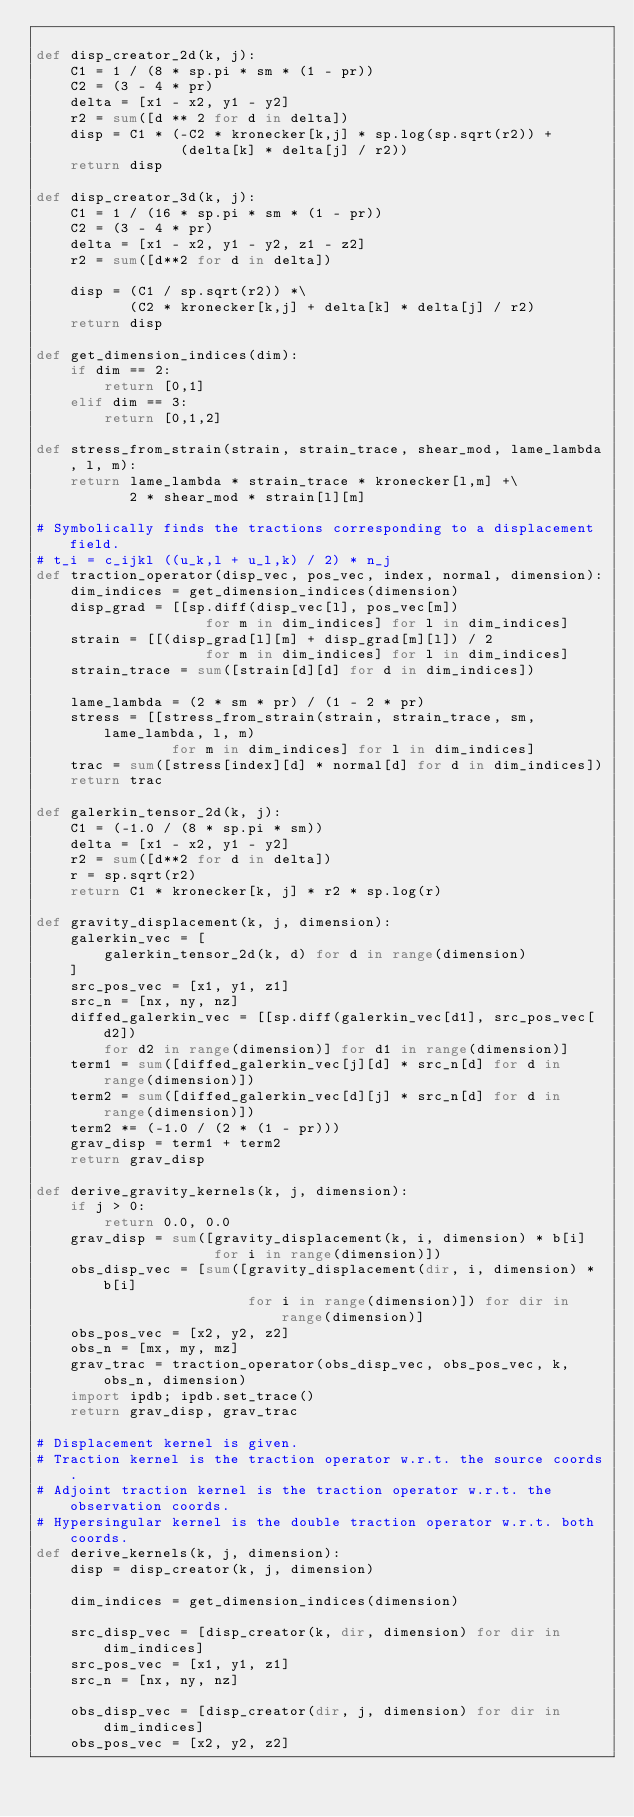Convert code to text. <code><loc_0><loc_0><loc_500><loc_500><_Python_>
def disp_creator_2d(k, j):
    C1 = 1 / (8 * sp.pi * sm * (1 - pr))
    C2 = (3 - 4 * pr)
    delta = [x1 - x2, y1 - y2]
    r2 = sum([d ** 2 for d in delta])
    disp = C1 * (-C2 * kronecker[k,j] * sp.log(sp.sqrt(r2)) +
                 (delta[k] * delta[j] / r2))
    return disp

def disp_creator_3d(k, j):
    C1 = 1 / (16 * sp.pi * sm * (1 - pr))
    C2 = (3 - 4 * pr)
    delta = [x1 - x2, y1 - y2, z1 - z2]
    r2 = sum([d**2 for d in delta])

    disp = (C1 / sp.sqrt(r2)) *\
           (C2 * kronecker[k,j] + delta[k] * delta[j] / r2)
    return disp

def get_dimension_indices(dim):
    if dim == 2:
        return [0,1]
    elif dim == 3:
        return [0,1,2]

def stress_from_strain(strain, strain_trace, shear_mod, lame_lambda, l, m):
    return lame_lambda * strain_trace * kronecker[l,m] +\
           2 * shear_mod * strain[l][m]

# Symbolically finds the tractions corresponding to a displacement field.
# t_i = c_ijkl ((u_k,l + u_l,k) / 2) * n_j
def traction_operator(disp_vec, pos_vec, index, normal, dimension):
    dim_indices = get_dimension_indices(dimension)
    disp_grad = [[sp.diff(disp_vec[l], pos_vec[m])
                    for m in dim_indices] for l in dim_indices]
    strain = [[(disp_grad[l][m] + disp_grad[m][l]) / 2
                    for m in dim_indices] for l in dim_indices]
    strain_trace = sum([strain[d][d] for d in dim_indices])

    lame_lambda = (2 * sm * pr) / (1 - 2 * pr)
    stress = [[stress_from_strain(strain, strain_trace, sm, lame_lambda, l, m)
                for m in dim_indices] for l in dim_indices]
    trac = sum([stress[index][d] * normal[d] for d in dim_indices])
    return trac

def galerkin_tensor_2d(k, j):
    C1 = (-1.0 / (8 * sp.pi * sm))
    delta = [x1 - x2, y1 - y2]
    r2 = sum([d**2 for d in delta])
    r = sp.sqrt(r2)
    return C1 * kronecker[k, j] * r2 * sp.log(r)

def gravity_displacement(k, j, dimension):
    galerkin_vec = [
        galerkin_tensor_2d(k, d) for d in range(dimension)
    ]
    src_pos_vec = [x1, y1, z1]
    src_n = [nx, ny, nz]
    diffed_galerkin_vec = [[sp.diff(galerkin_vec[d1], src_pos_vec[d2])
        for d2 in range(dimension)] for d1 in range(dimension)]
    term1 = sum([diffed_galerkin_vec[j][d] * src_n[d] for d in range(dimension)])
    term2 = sum([diffed_galerkin_vec[d][j] * src_n[d] for d in range(dimension)])
    term2 *= (-1.0 / (2 * (1 - pr)))
    grav_disp = term1 + term2
    return grav_disp

def derive_gravity_kernels(k, j, dimension):
    if j > 0:
        return 0.0, 0.0
    grav_disp = sum([gravity_displacement(k, i, dimension) * b[i]
                     for i in range(dimension)])
    obs_disp_vec = [sum([gravity_displacement(dir, i, dimension) * b[i]
                         for i in range(dimension)]) for dir in range(dimension)]
    obs_pos_vec = [x2, y2, z2]
    obs_n = [mx, my, mz]
    grav_trac = traction_operator(obs_disp_vec, obs_pos_vec, k, obs_n, dimension)
    import ipdb; ipdb.set_trace()
    return grav_disp, grav_trac

# Displacement kernel is given.
# Traction kernel is the traction operator w.r.t. the source coords.
# Adjoint traction kernel is the traction operator w.r.t. the observation coords.
# Hypersingular kernel is the double traction operator w.r.t. both coords.
def derive_kernels(k, j, dimension):
    disp = disp_creator(k, j, dimension)

    dim_indices = get_dimension_indices(dimension)

    src_disp_vec = [disp_creator(k, dir, dimension) for dir in dim_indices]
    src_pos_vec = [x1, y1, z1]
    src_n = [nx, ny, nz]

    obs_disp_vec = [disp_creator(dir, j, dimension) for dir in dim_indices]
    obs_pos_vec = [x2, y2, z2]</code> 